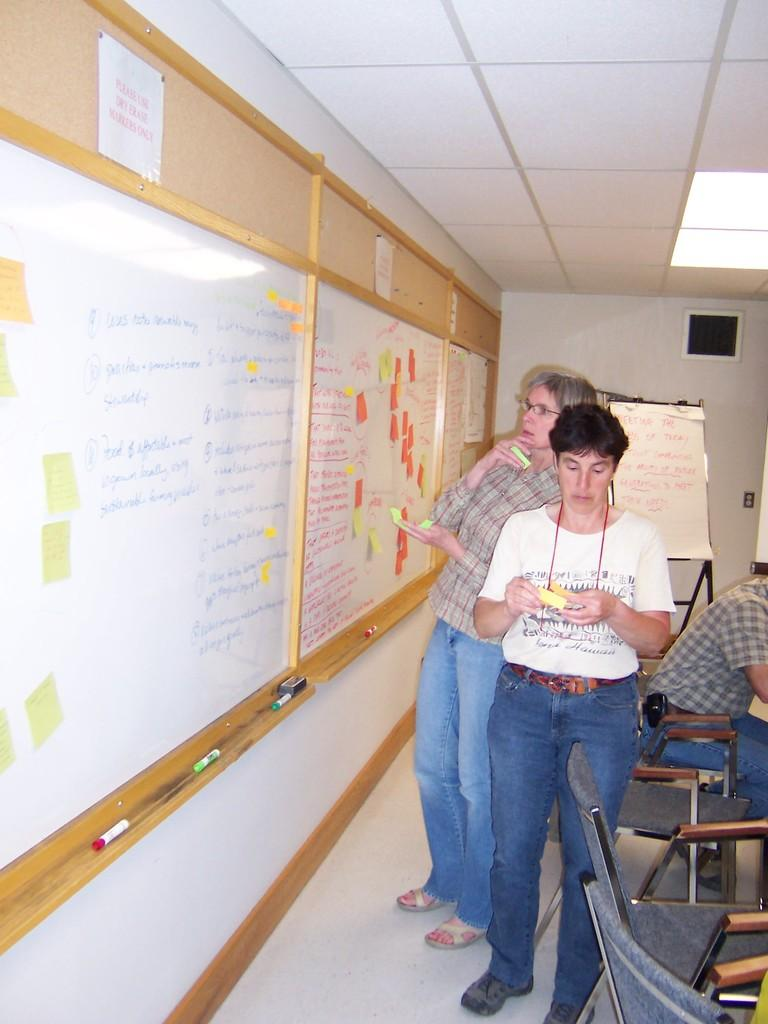How many people are in the image? There are three persons in the image. What are the positions of the people in the image? One person is sitting on a chair, and two persons are standing. What are the people looking at in the image? All three persons are looking at a board. What can be seen in the background of the image? There is a notice, a wall, and a light in the background. What type of volcano can be seen erupting in the background of the image? There is no volcano present in the image; it features three people looking at a board with a notice, wall, and light in the background. What scientific detail can be observed in the image? The image does not depict any specific scientific detail; it shows three people looking at a board and the background elements. 